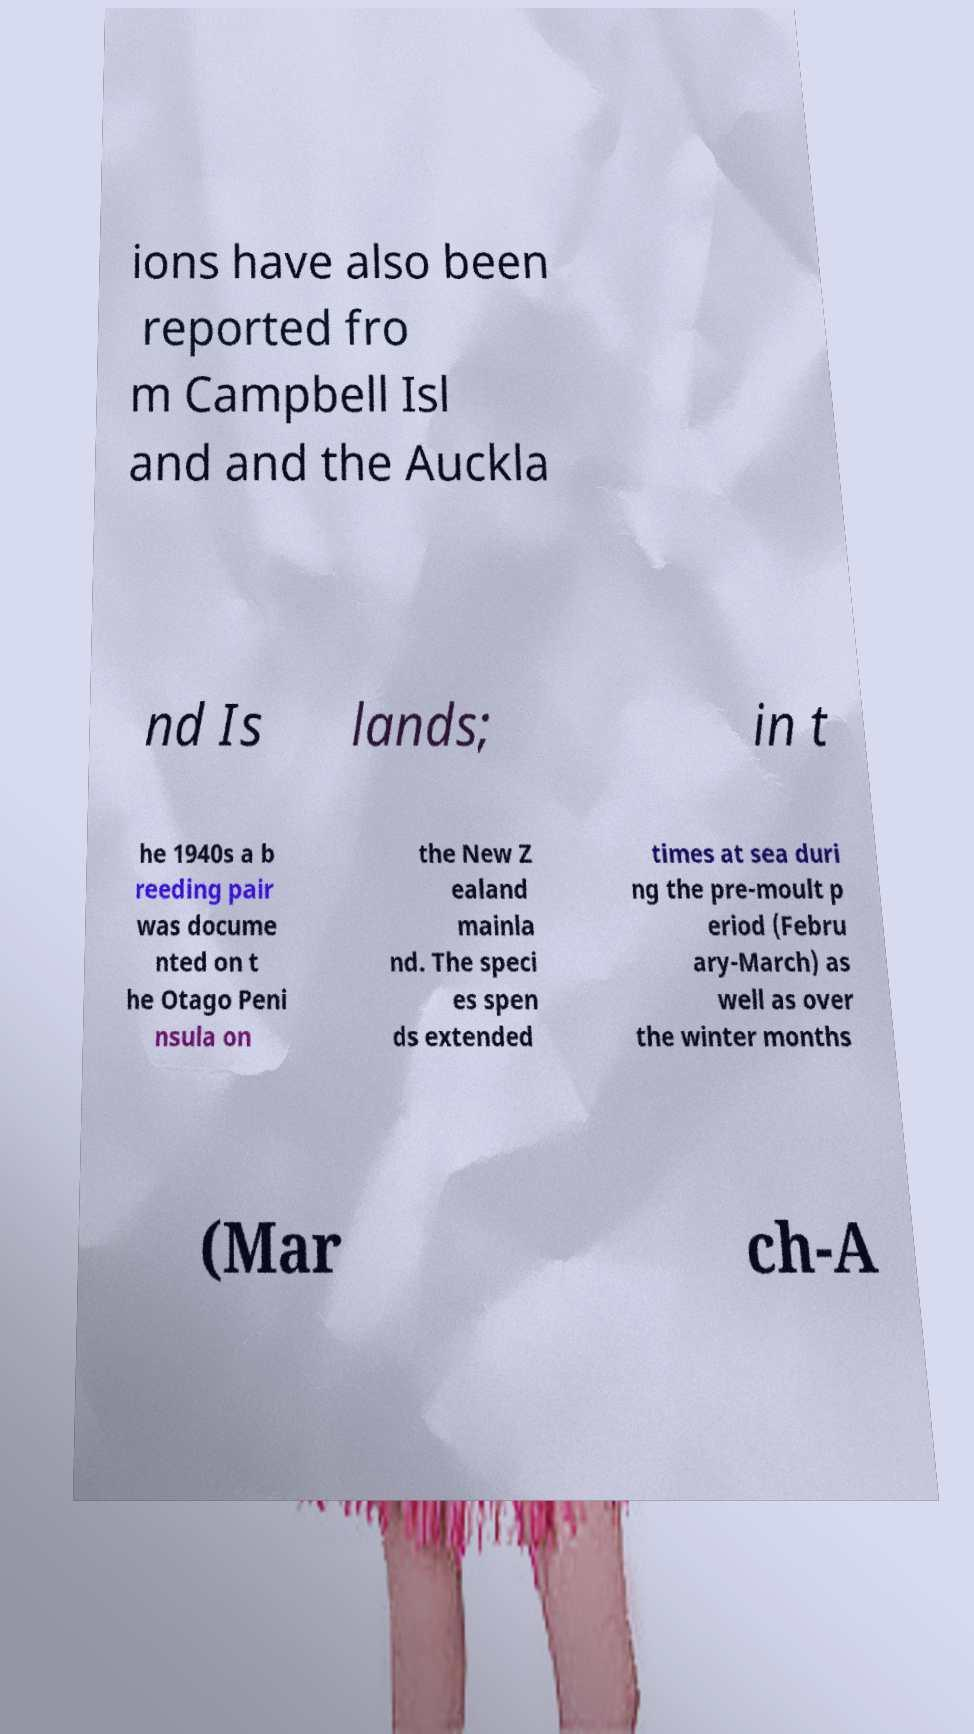Can you accurately transcribe the text from the provided image for me? ions have also been reported fro m Campbell Isl and and the Auckla nd Is lands; in t he 1940s a b reeding pair was docume nted on t he Otago Peni nsula on the New Z ealand mainla nd. The speci es spen ds extended times at sea duri ng the pre-moult p eriod (Febru ary-March) as well as over the winter months (Mar ch-A 